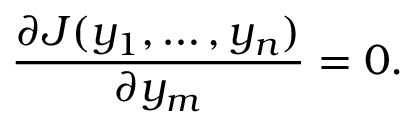Convert formula to latex. <formula><loc_0><loc_0><loc_500><loc_500>{ \frac { \partial J ( y _ { 1 } , \dots , y _ { n } ) } { \partial y _ { m } } } = 0 .</formula> 